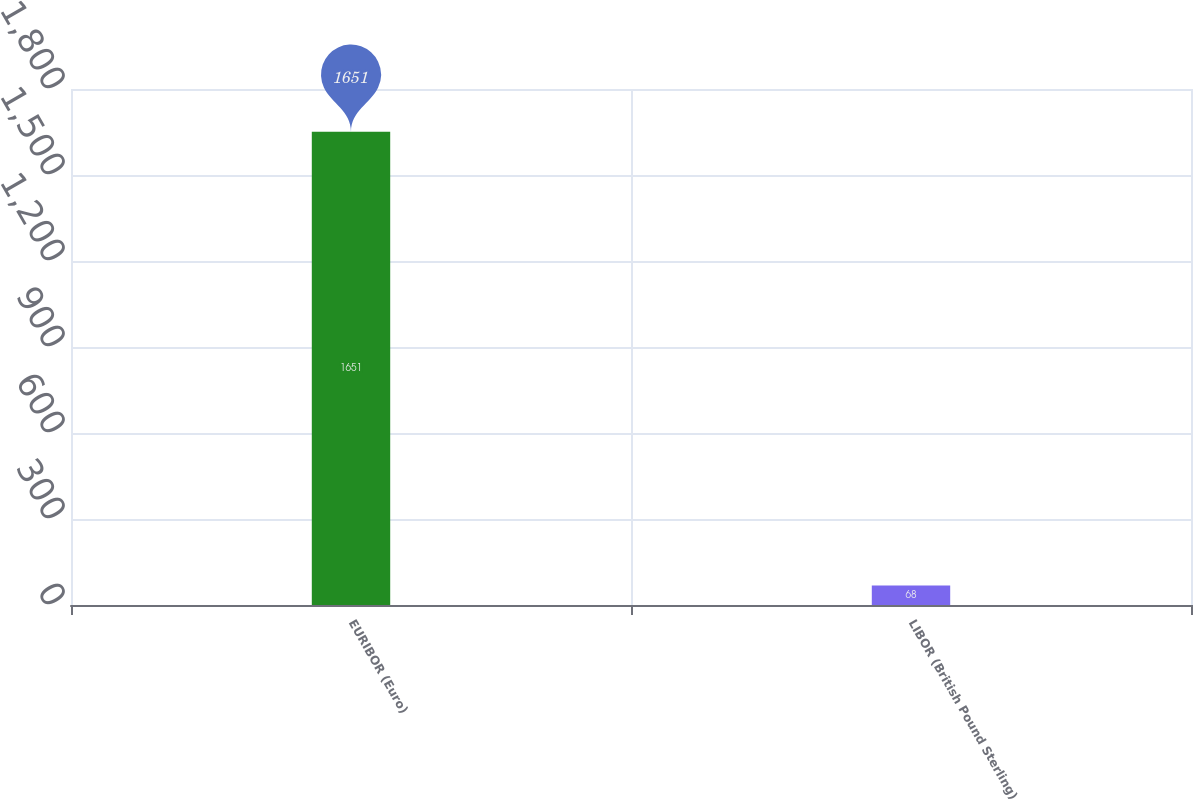Convert chart. <chart><loc_0><loc_0><loc_500><loc_500><bar_chart><fcel>EURIBOR (Euro)<fcel>LIBOR (British Pound Sterling)<nl><fcel>1651<fcel>68<nl></chart> 